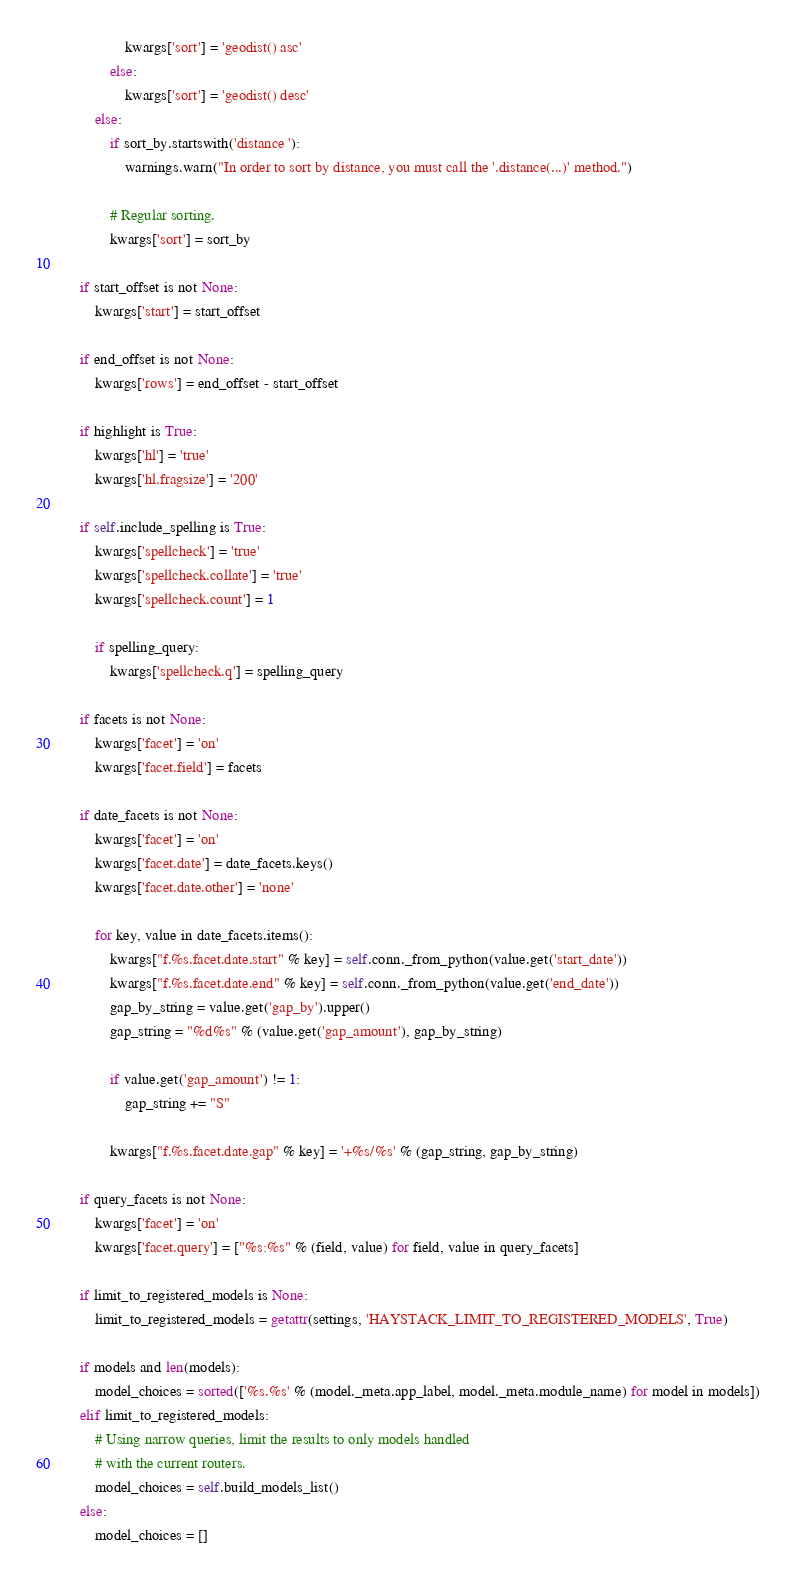<code> <loc_0><loc_0><loc_500><loc_500><_Python_>                    kwargs['sort'] = 'geodist() asc'
                else:
                    kwargs['sort'] = 'geodist() desc'
            else:
                if sort_by.startswith('distance '):
                    warnings.warn("In order to sort by distance, you must call the '.distance(...)' method.")

                # Regular sorting.
                kwargs['sort'] = sort_by

        if start_offset is not None:
            kwargs['start'] = start_offset

        if end_offset is not None:
            kwargs['rows'] = end_offset - start_offset

        if highlight is True:
            kwargs['hl'] = 'true'
            kwargs['hl.fragsize'] = '200'

        if self.include_spelling is True:
            kwargs['spellcheck'] = 'true'
            kwargs['spellcheck.collate'] = 'true'
            kwargs['spellcheck.count'] = 1

            if spelling_query:
                kwargs['spellcheck.q'] = spelling_query

        if facets is not None:
            kwargs['facet'] = 'on'
            kwargs['facet.field'] = facets

        if date_facets is not None:
            kwargs['facet'] = 'on'
            kwargs['facet.date'] = date_facets.keys()
            kwargs['facet.date.other'] = 'none'

            for key, value in date_facets.items():
                kwargs["f.%s.facet.date.start" % key] = self.conn._from_python(value.get('start_date'))
                kwargs["f.%s.facet.date.end" % key] = self.conn._from_python(value.get('end_date'))
                gap_by_string = value.get('gap_by').upper()
                gap_string = "%d%s" % (value.get('gap_amount'), gap_by_string)

                if value.get('gap_amount') != 1:
                    gap_string += "S"

                kwargs["f.%s.facet.date.gap" % key] = '+%s/%s' % (gap_string, gap_by_string)

        if query_facets is not None:
            kwargs['facet'] = 'on'
            kwargs['facet.query'] = ["%s:%s" % (field, value) for field, value in query_facets]

        if limit_to_registered_models is None:
            limit_to_registered_models = getattr(settings, 'HAYSTACK_LIMIT_TO_REGISTERED_MODELS', True)

        if models and len(models):
            model_choices = sorted(['%s.%s' % (model._meta.app_label, model._meta.module_name) for model in models])
        elif limit_to_registered_models:
            # Using narrow queries, limit the results to only models handled
            # with the current routers.
            model_choices = self.build_models_list()
        else:
            model_choices = []
</code> 